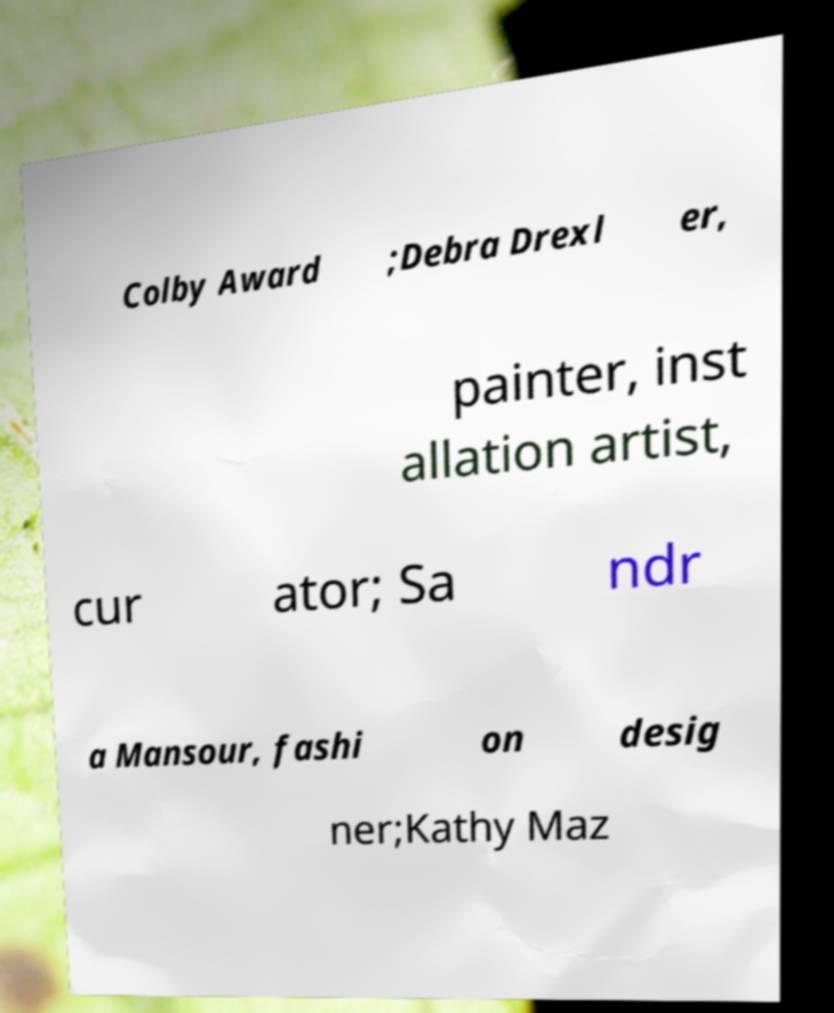Could you extract and type out the text from this image? Colby Award ;Debra Drexl er, painter, inst allation artist, cur ator; Sa ndr a Mansour, fashi on desig ner;Kathy Maz 